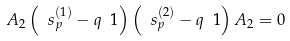<formula> <loc_0><loc_0><loc_500><loc_500>A _ { 2 } \left ( \ s _ { p } ^ { ( 1 ) } - q \ { 1 } \right ) \left ( \ s _ { p } ^ { ( 2 ) } - q \ { 1 } \right ) A _ { 2 } = 0 \,</formula> 